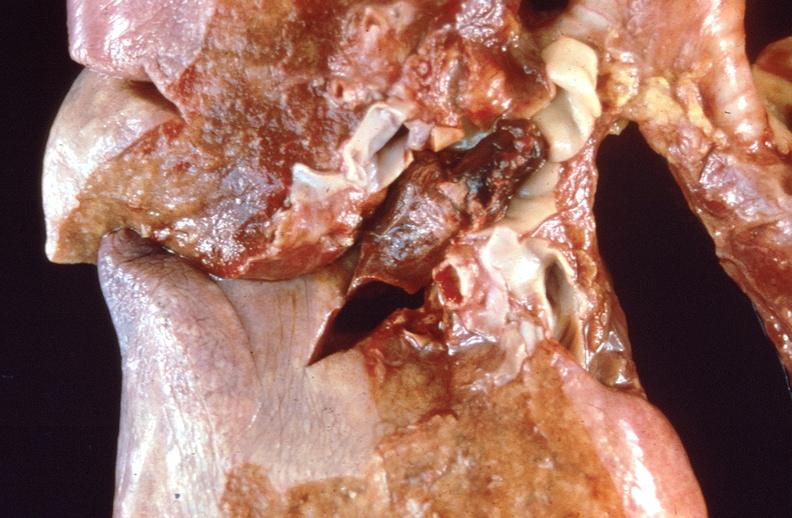s respiratory present?
Answer the question using a single word or phrase. Yes 